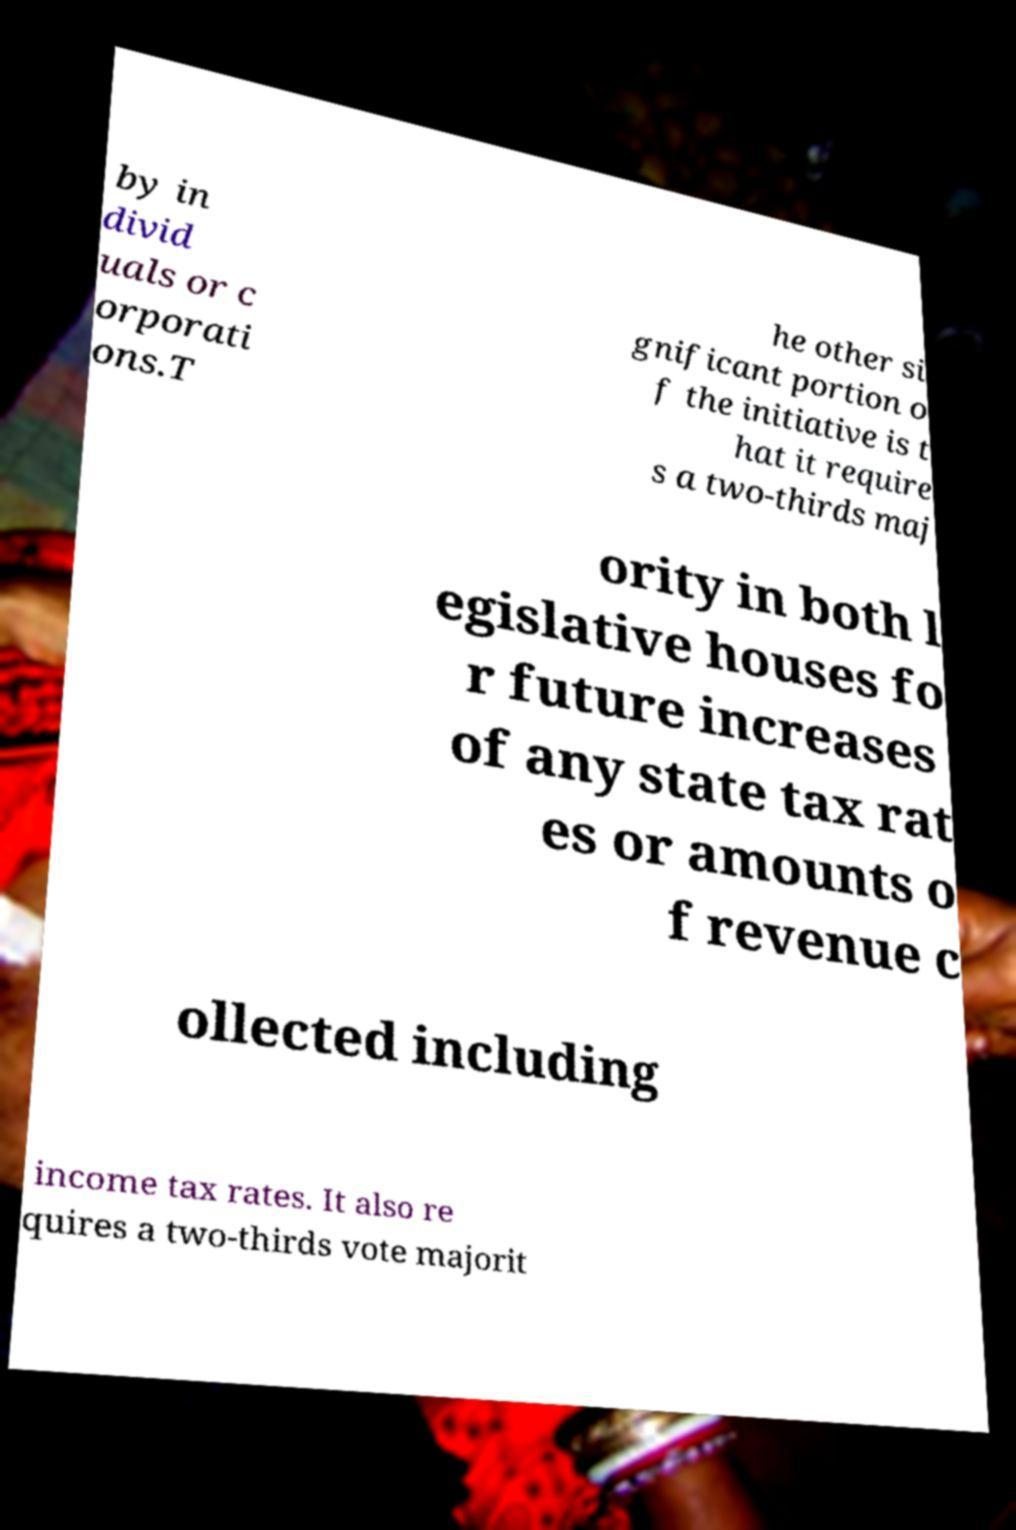Could you assist in decoding the text presented in this image and type it out clearly? by in divid uals or c orporati ons.T he other si gnificant portion o f the initiative is t hat it require s a two-thirds maj ority in both l egislative houses fo r future increases of any state tax rat es or amounts o f revenue c ollected including income tax rates. It also re quires a two-thirds vote majorit 